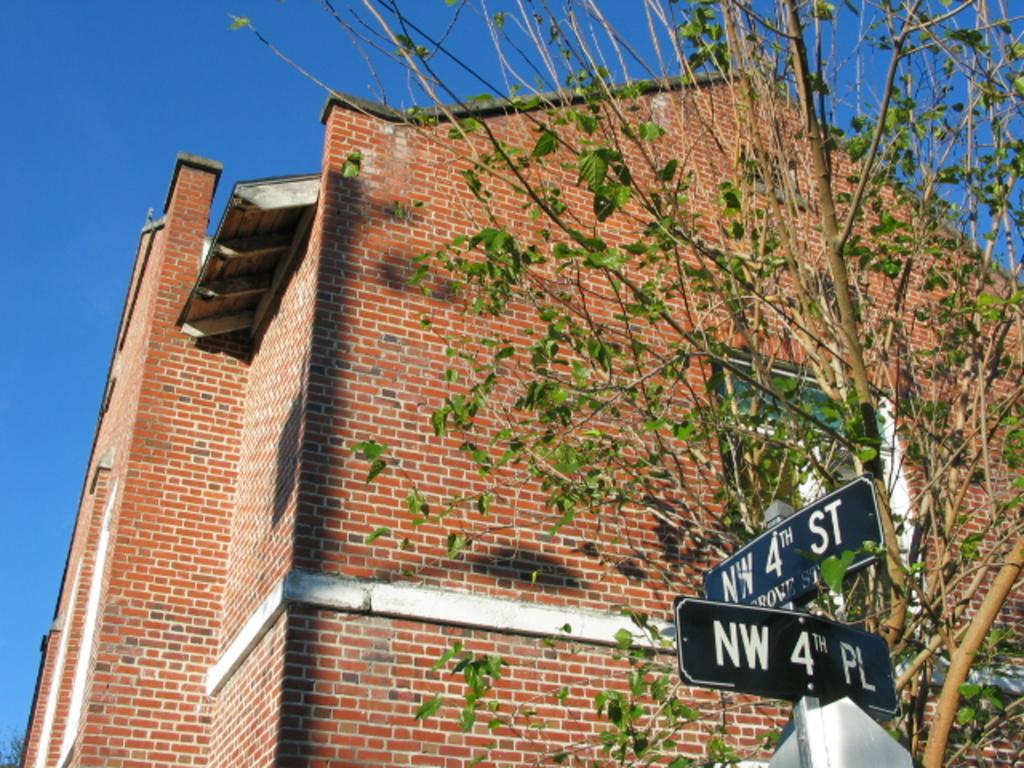What is the street name?
Your answer should be compact. Nw 4th st. 